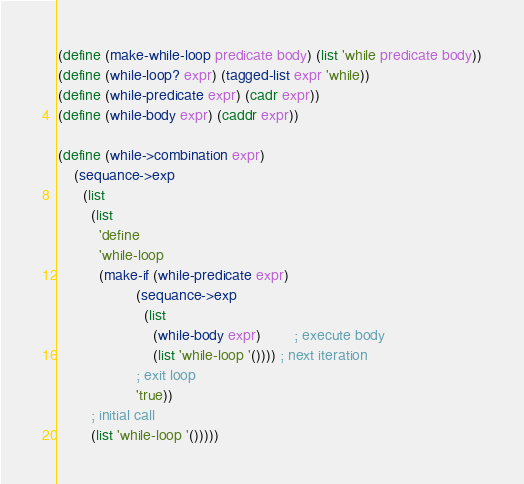Convert code to text. <code><loc_0><loc_0><loc_500><loc_500><_Scheme_>(define (make-while-loop predicate body) (list 'while predicate body))
(define (while-loop? expr) (tagged-list expr 'while))
(define (while-predicate expr) (cadr expr))
(define (while-body expr) (caddr expr))

(define (while->combination expr)
    (sequance->exp
      (list
        (list
          'define
          'while-loop
          (make-if (while-predicate expr)
                   (sequance->exp
                     (list
                       (while-body expr)        ; execute body
                       (list 'while-loop '()))) ; next iteration
                   ; exit loop
                   'true))
        ; initial call
        (list 'while-loop '()))))

</code> 